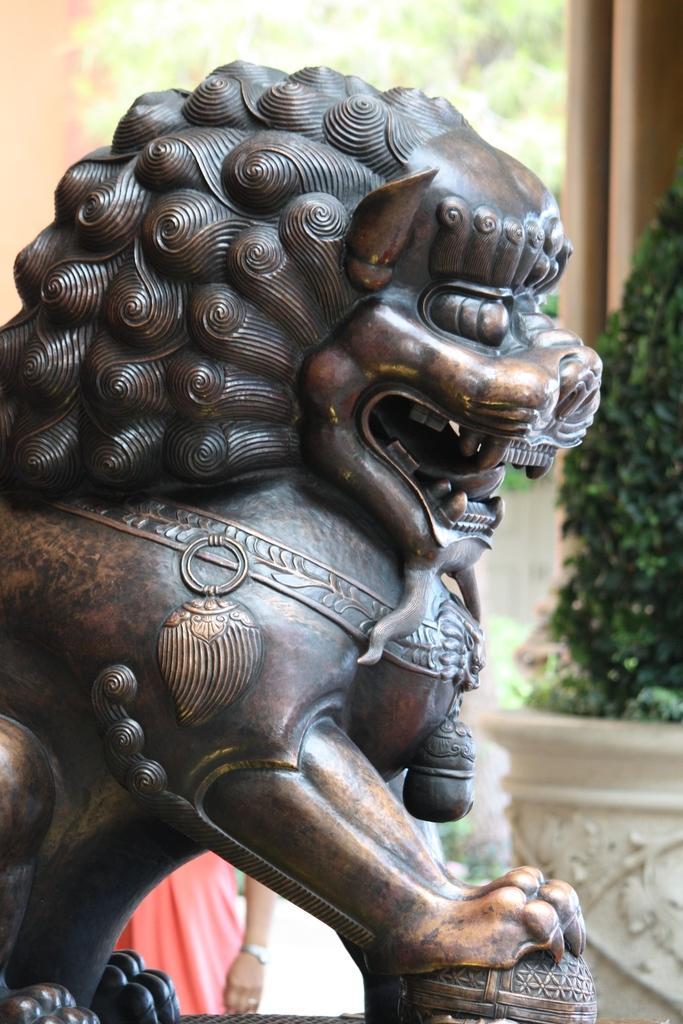Could you give a brief overview of what you see in this image? In this picture there is a sculpture of a lion and there is a person standing behind the sculpture. At the back there are pillars and trees and there is a plant. 